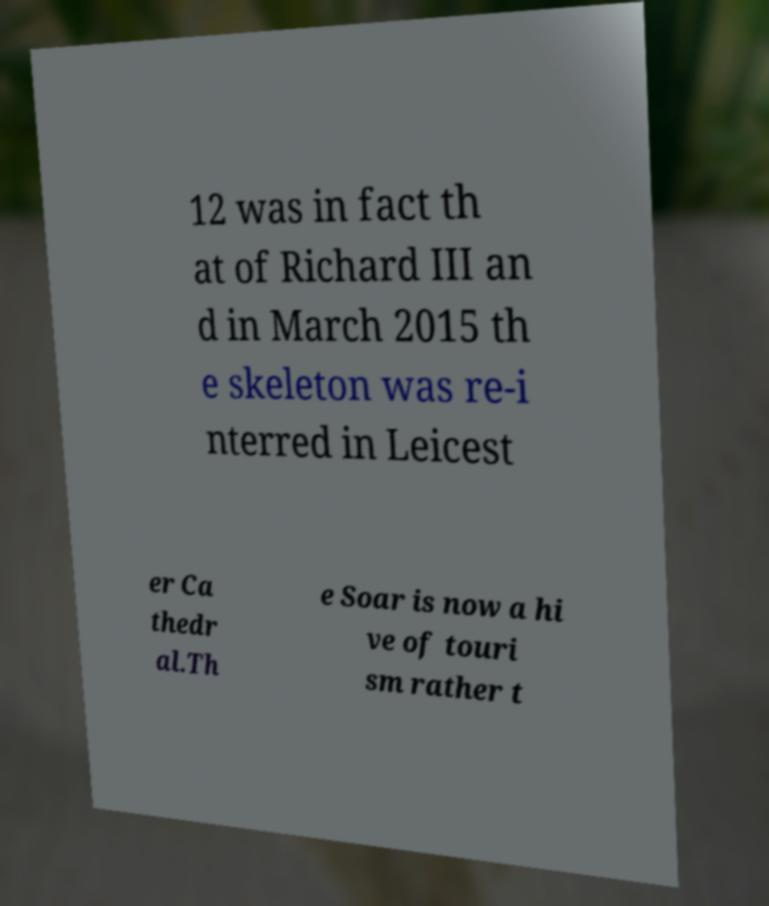There's text embedded in this image that I need extracted. Can you transcribe it verbatim? 12 was in fact th at of Richard III an d in March 2015 th e skeleton was re-i nterred in Leicest er Ca thedr al.Th e Soar is now a hi ve of touri sm rather t 